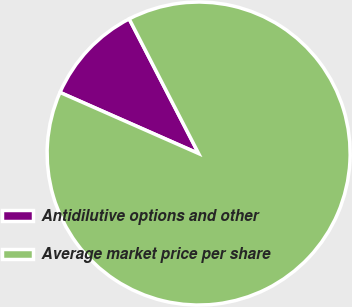Convert chart to OTSL. <chart><loc_0><loc_0><loc_500><loc_500><pie_chart><fcel>Antidilutive options and other<fcel>Average market price per share<nl><fcel>10.81%<fcel>89.19%<nl></chart> 